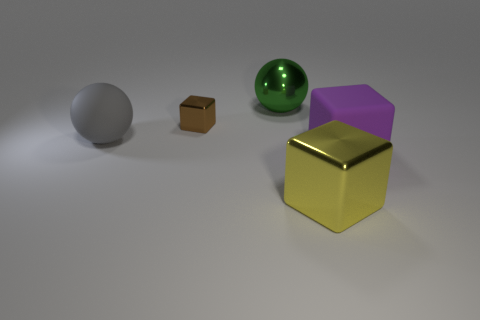There is a small brown shiny object; how many metallic cubes are behind it?
Provide a short and direct response. 0. Is the block behind the large rubber block made of the same material as the yellow object?
Offer a terse response. Yes. How many other objects are there of the same shape as the large gray matte thing?
Ensure brevity in your answer.  1. What number of big blocks are on the right side of the big metallic thing that is in front of the big gray sphere that is in front of the big green sphere?
Ensure brevity in your answer.  1. What color is the object behind the tiny brown thing?
Ensure brevity in your answer.  Green. There is a metal cube behind the large rubber block; does it have the same color as the large metallic ball?
Make the answer very short. No. The other yellow metallic object that is the same shape as the small object is what size?
Your answer should be compact. Large. Is there any other thing that has the same size as the brown object?
Ensure brevity in your answer.  No. There is a ball to the left of the block to the left of the large metallic thing behind the gray rubber ball; what is it made of?
Ensure brevity in your answer.  Rubber. Is the number of large blocks that are to the right of the gray object greater than the number of large things in front of the small brown thing?
Ensure brevity in your answer.  No. 